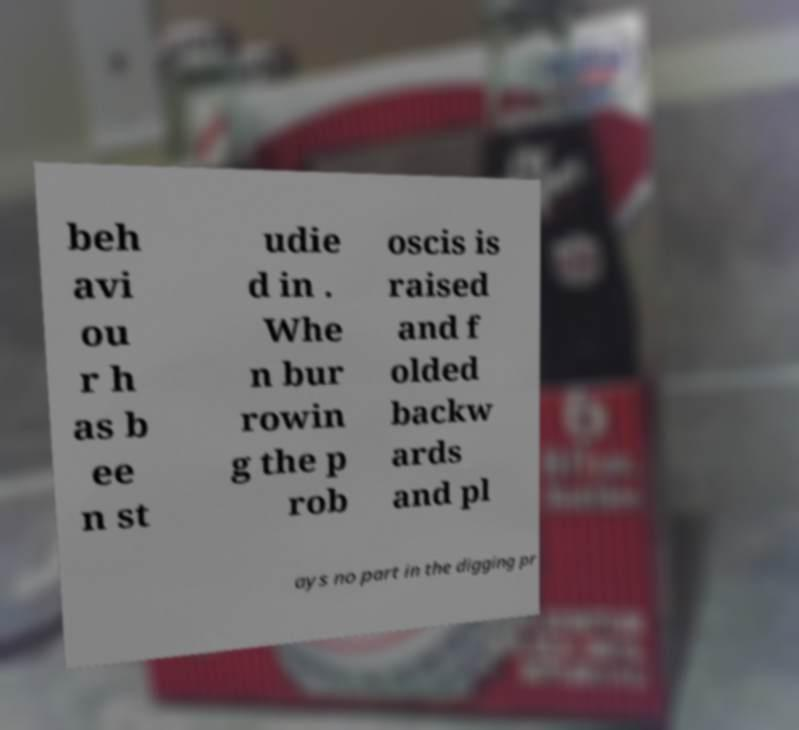Please read and relay the text visible in this image. What does it say? beh avi ou r h as b ee n st udie d in . Whe n bur rowin g the p rob oscis is raised and f olded backw ards and pl ays no part in the digging pr 